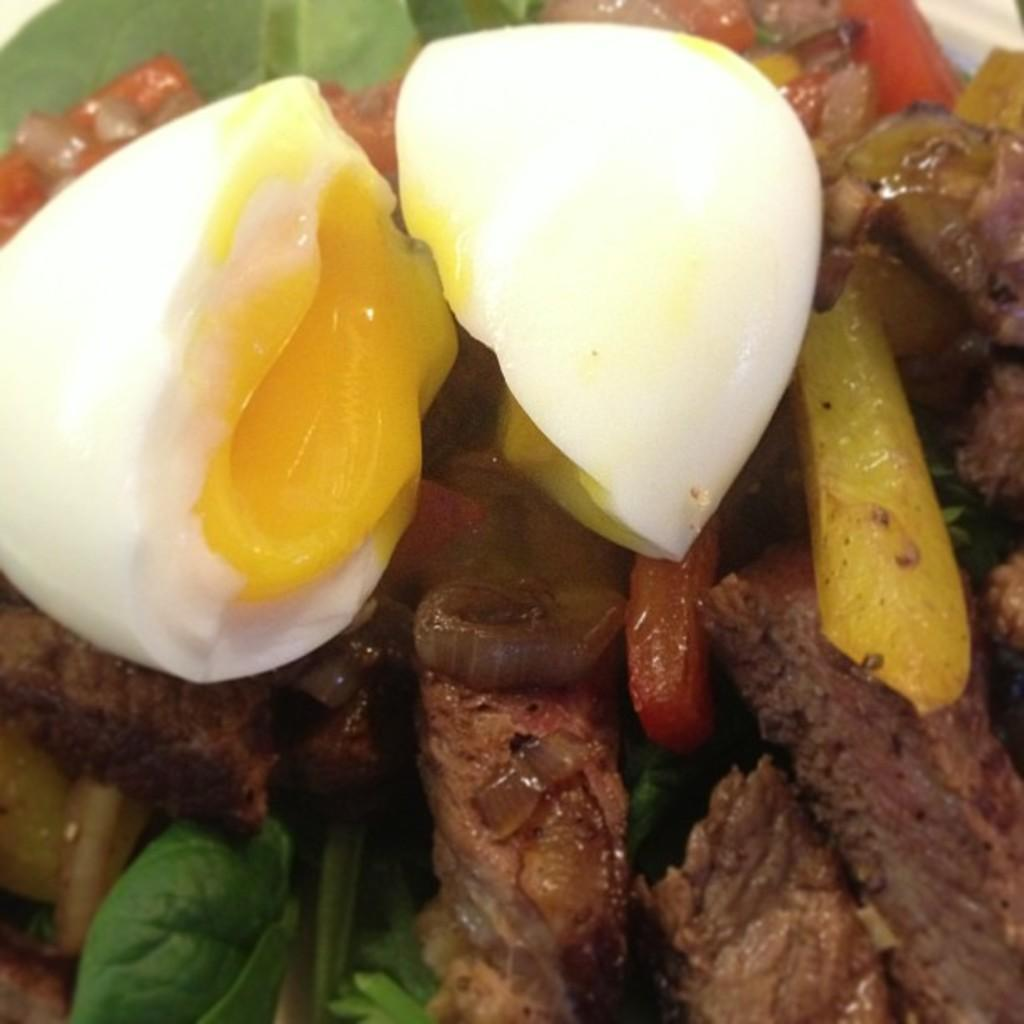What type of food is visible in the image? There is a boiled egg in the image. What is the egg placed in? There is a bowl in the image. What other type of food can be seen in the bowl? There is another meat item present in the bowl. Who is the creator of the boiled egg in the image? There is no information about the creator of the boiled egg in the image. 